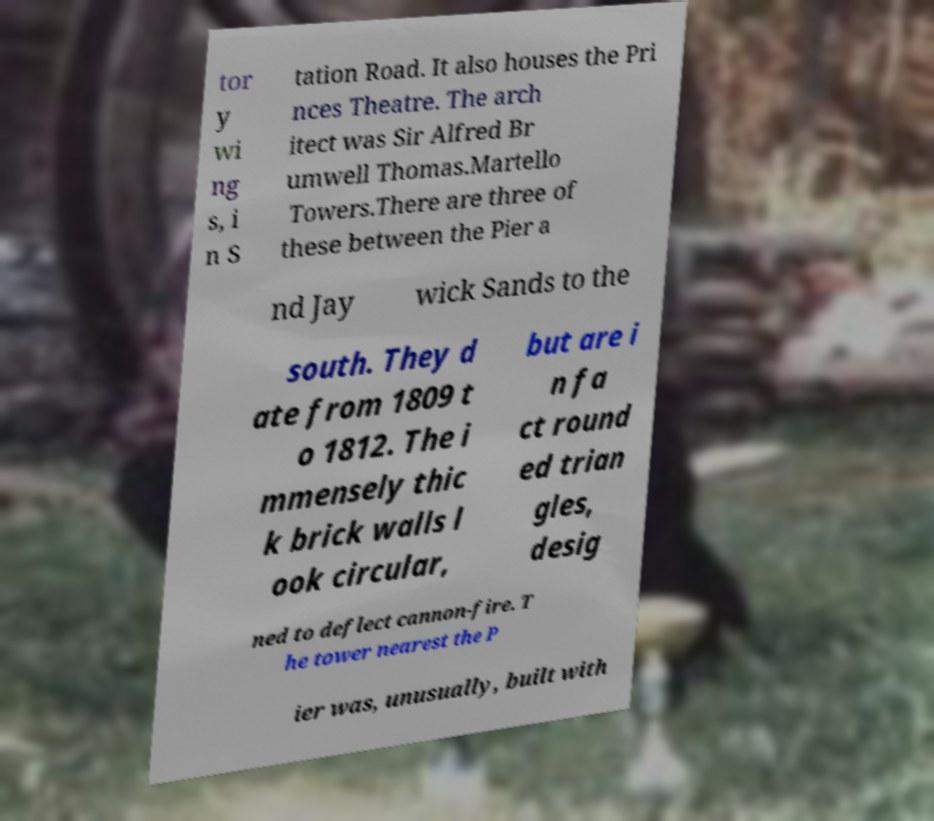There's text embedded in this image that I need extracted. Can you transcribe it verbatim? tor y wi ng s, i n S tation Road. It also houses the Pri nces Theatre. The arch itect was Sir Alfred Br umwell Thomas.Martello Towers.There are three of these between the Pier a nd Jay wick Sands to the south. They d ate from 1809 t o 1812. The i mmensely thic k brick walls l ook circular, but are i n fa ct round ed trian gles, desig ned to deflect cannon-fire. T he tower nearest the P ier was, unusually, built with 